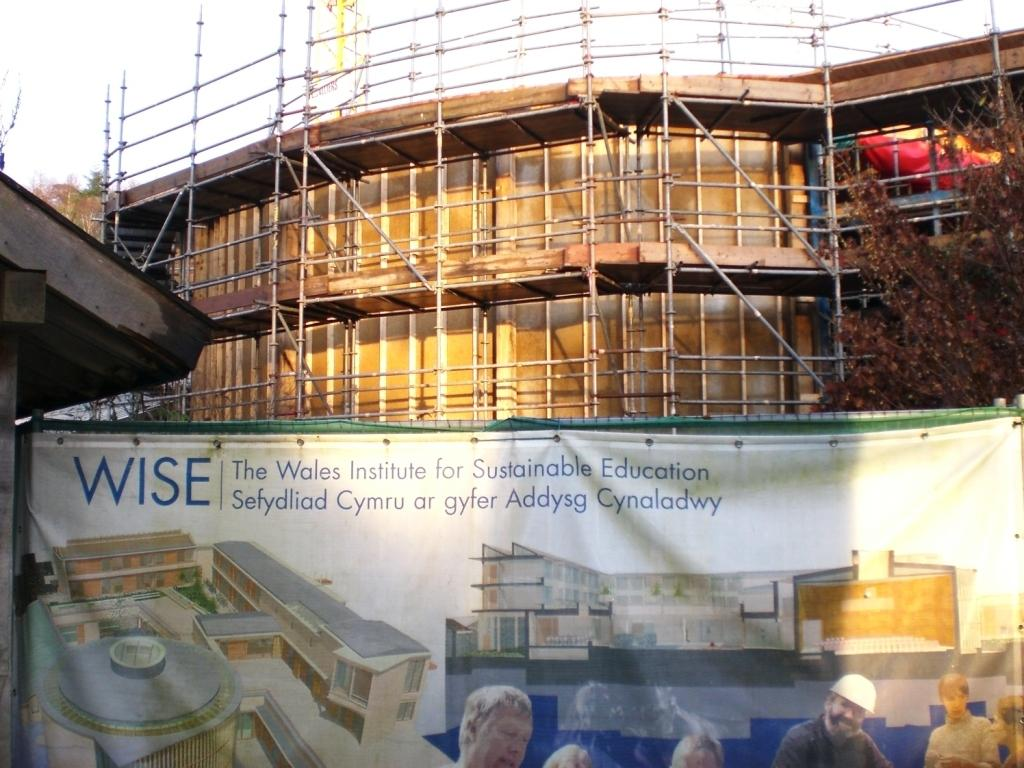What is the main subject of the image? The main subject of the image is a building under construction. Are there any additional features or elements in the image? Yes, there is a banner with different images at the bottom of the building. What can be seen on the right side of the image? There are trees on the right side of the image. What type of structure is being pulled by a basket in the image? There is no structure being pulled by a basket in the image; it only shows a building under construction and trees on the right side. 